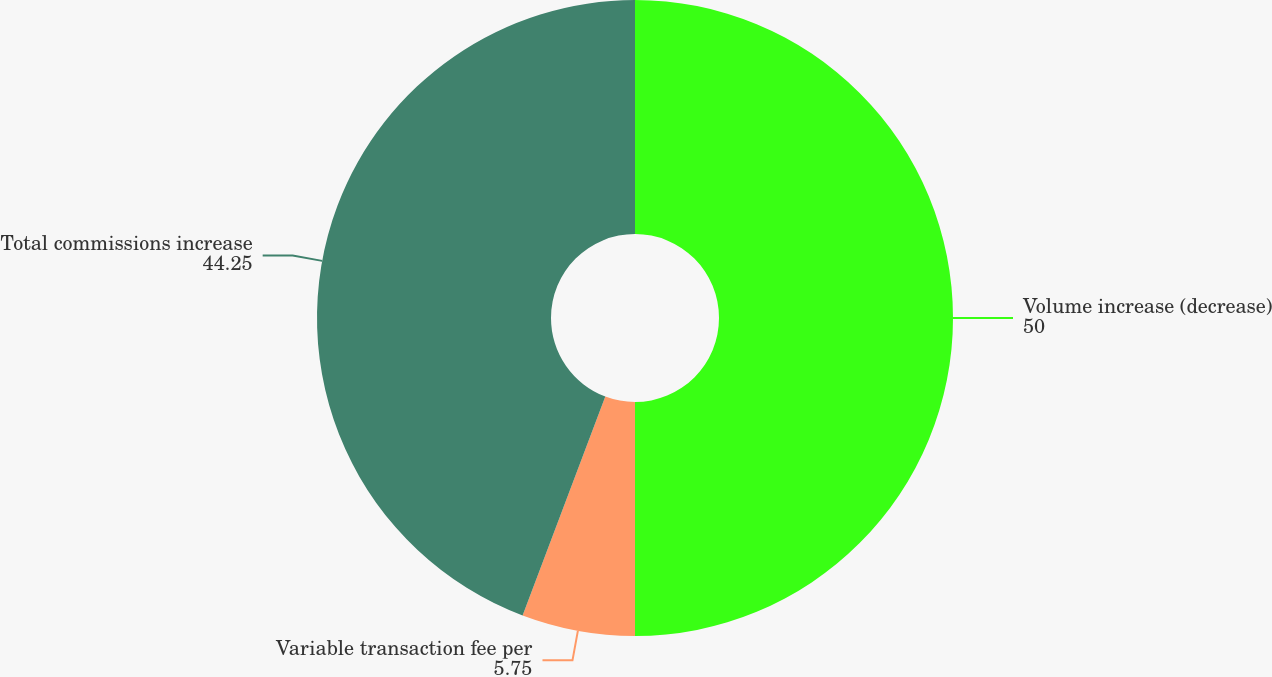Convert chart to OTSL. <chart><loc_0><loc_0><loc_500><loc_500><pie_chart><fcel>Volume increase (decrease)<fcel>Variable transaction fee per<fcel>Total commissions increase<nl><fcel>50.0%<fcel>5.75%<fcel>44.25%<nl></chart> 